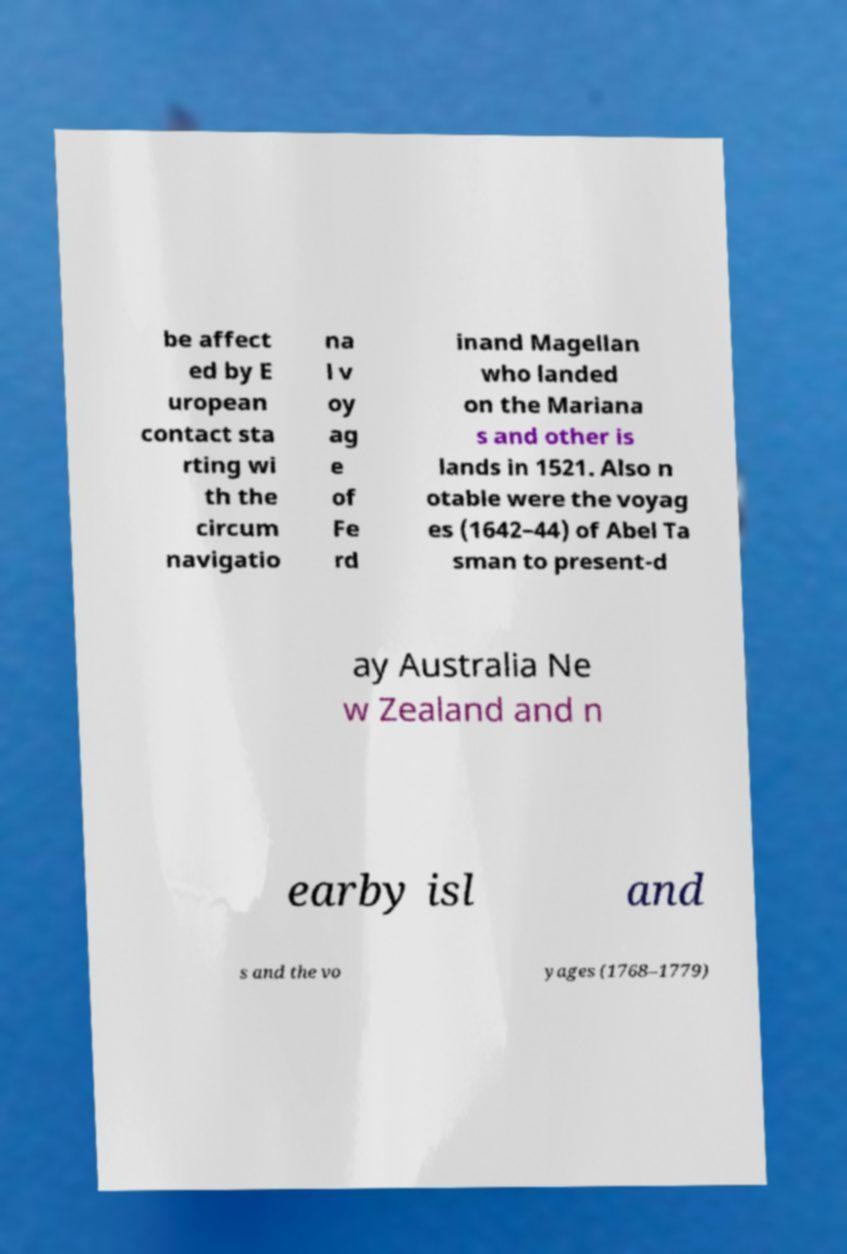Can you read and provide the text displayed in the image?This photo seems to have some interesting text. Can you extract and type it out for me? be affect ed by E uropean contact sta rting wi th the circum navigatio na l v oy ag e of Fe rd inand Magellan who landed on the Mariana s and other is lands in 1521. Also n otable were the voyag es (1642–44) of Abel Ta sman to present-d ay Australia Ne w Zealand and n earby isl and s and the vo yages (1768–1779) 